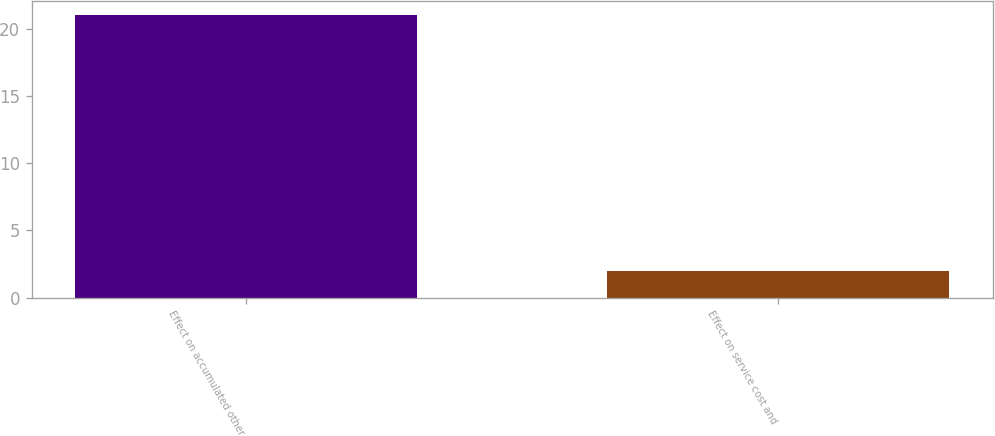Convert chart to OTSL. <chart><loc_0><loc_0><loc_500><loc_500><bar_chart><fcel>Effect on accumulated other<fcel>Effect on service cost and<nl><fcel>21<fcel>2<nl></chart> 